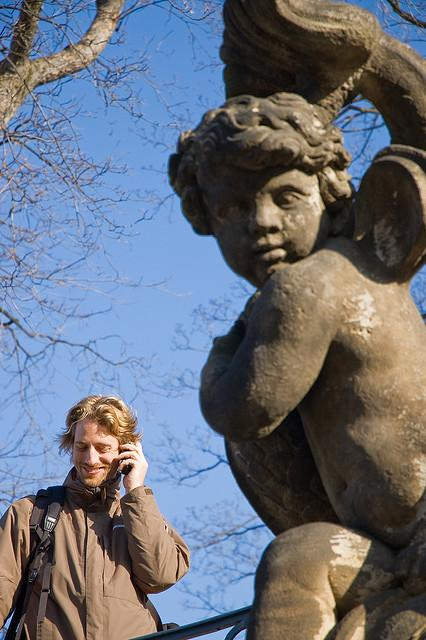What is the grey statue supposed to be? angel 